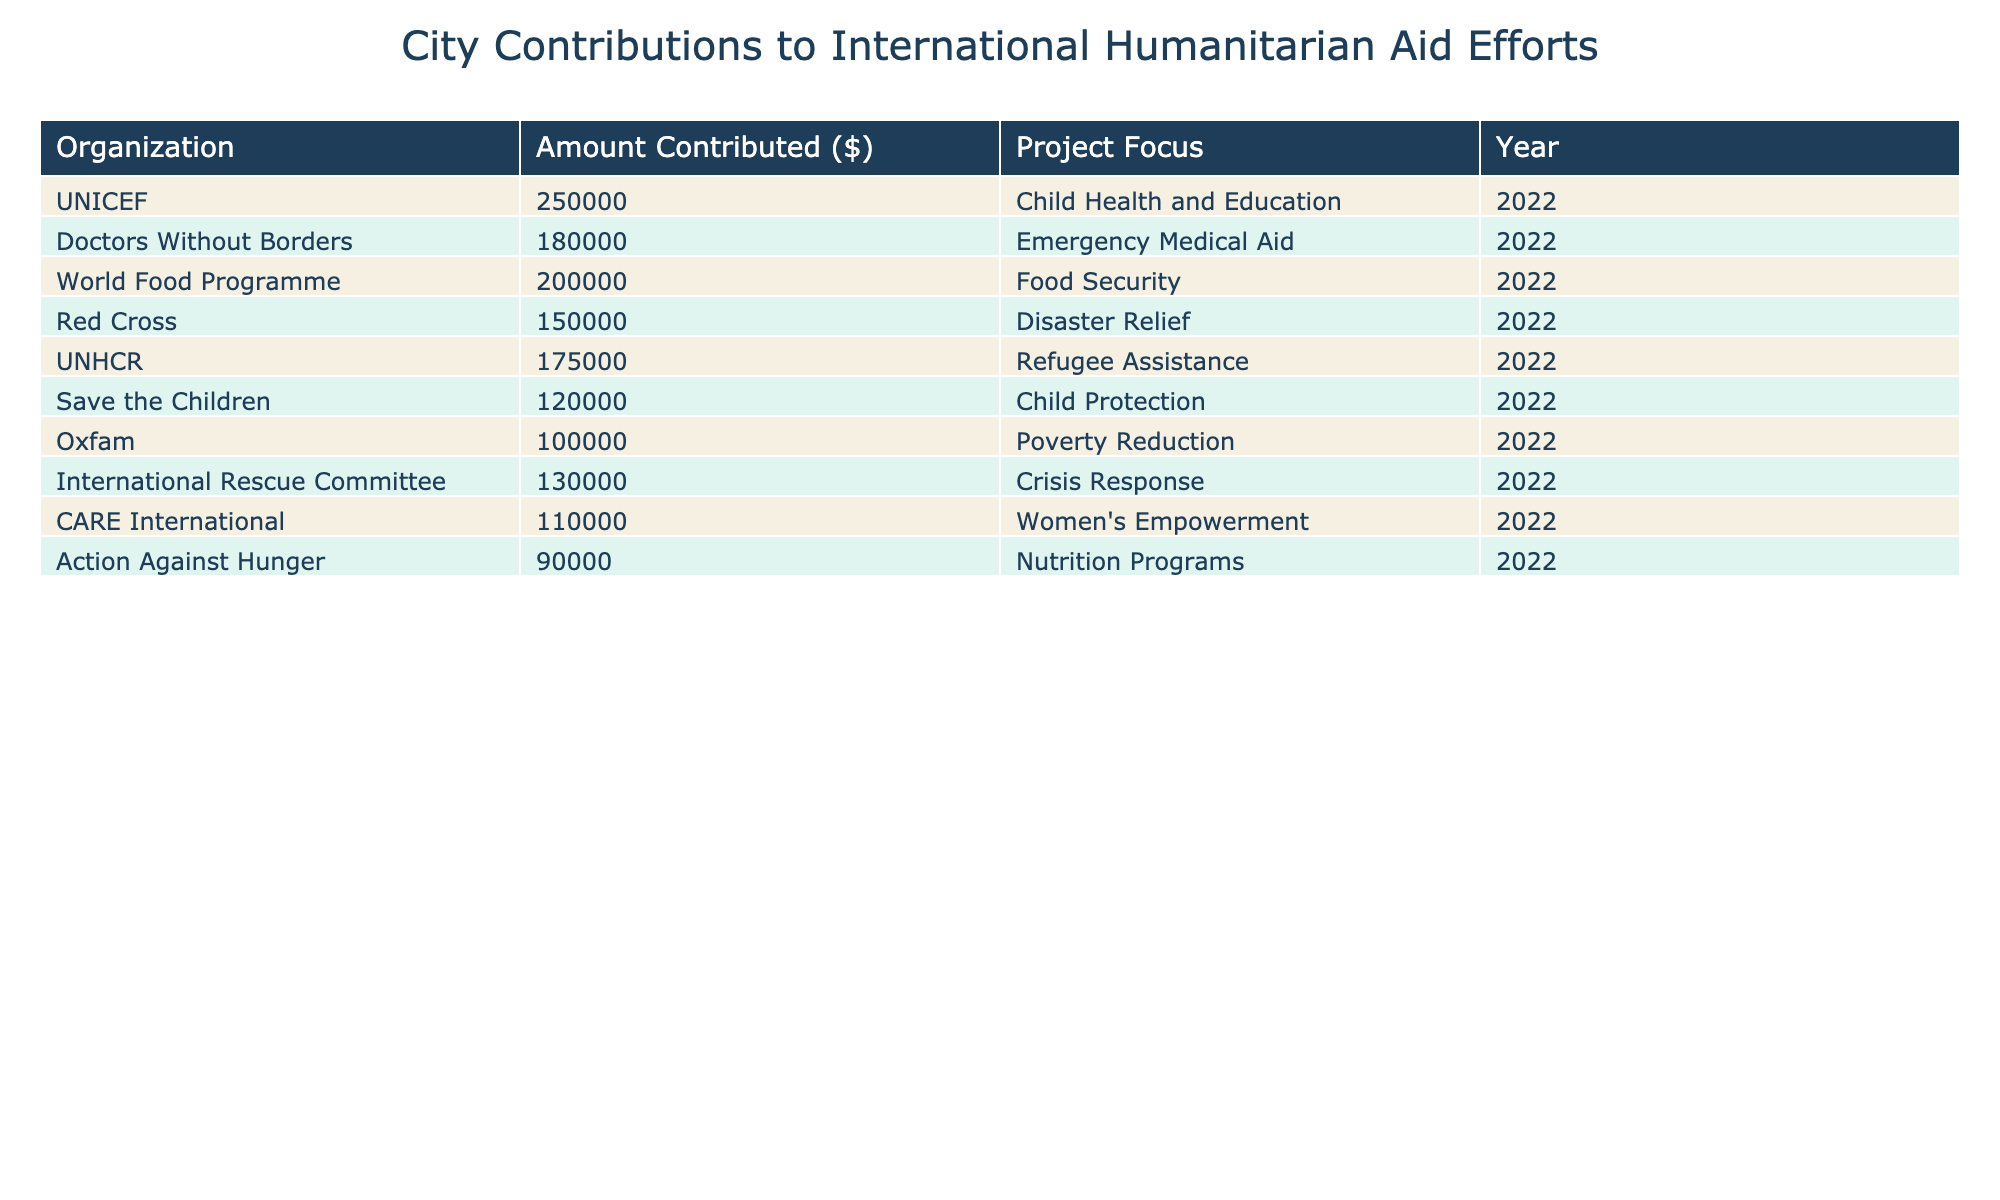What organization received the highest contribution? By reviewing the "Amount Contributed ($)" column, we find that UNICEF has the highest value listed at 250,000.
Answer: UNICEF What is the total amount contributed to emergency-related projects? The organizations focusing on emergency-related projects are Doctors Without Borders and the Red Cross. Their contributions are 180,000 and 150,000 respectively. When summed, 180,000 + 150,000 = 330,000.
Answer: 330,000 Did the organization Oxfam receive more than 100,000? Looking at the "Amount Contributed ($)" for Oxfam, which is 100,000, we see it is equal, not more.
Answer: No Which organization focuses on the highest number of child-related projects? The organizations involved with child-related projects are UNICEF (Child Health and Education) and Save the Children (Child Protection). Both are single projects but UNICEF has a higher contribution amount of 250,000 compared to 120,000.
Answer: UNICEF What is the median contribution amount among the organizations listed? To find the median, we first list the contributions in ascending order: 90,000, 100,000, 110,000, 120,000, 130,000, 150,000, 175,000, 180,000, 200,000, 250,000. As there are 10 values (even count), the median will be the average of the 5th and 6th values; (130,000 + 150,000) / 2 = 140,000.
Answer: 140,000 How many organizations contributed amounts greater than 150,000? By examining each value, we see UNICEF (250,000), World Food Programme (200,000), and Doctors Without Borders (180,000) are the only ones greater than 150,000. In total, there are three organizations.
Answer: 3 What contribution amount does the organization focused on women's empowerment have? The organization CARE International focuses on women's empowerment and received a contribution of 110,000 dollars.
Answer: 110,000 What percentage of the total contributions did Save the Children receive? First, we calculate the total contribution: 250,000 + 180,000 + 200,000 + 150,000 + 175,000 + 120,000 + 100,000 + 130,000 + 110,000 + 90,000 = 1,475,000. Save the Children received 120,000. To find the percentage: (120,000 / 1,475,000) * 100 ≈ 8.16%.
Answer: Approximately 8.16% Which project focus has the least amount of contributions? Reviewing the "Project Focus" column, Action Against Hunger focuses on Nutrition Programs, which has the lowest contribution of 90,000.
Answer: Nutrition Programs 